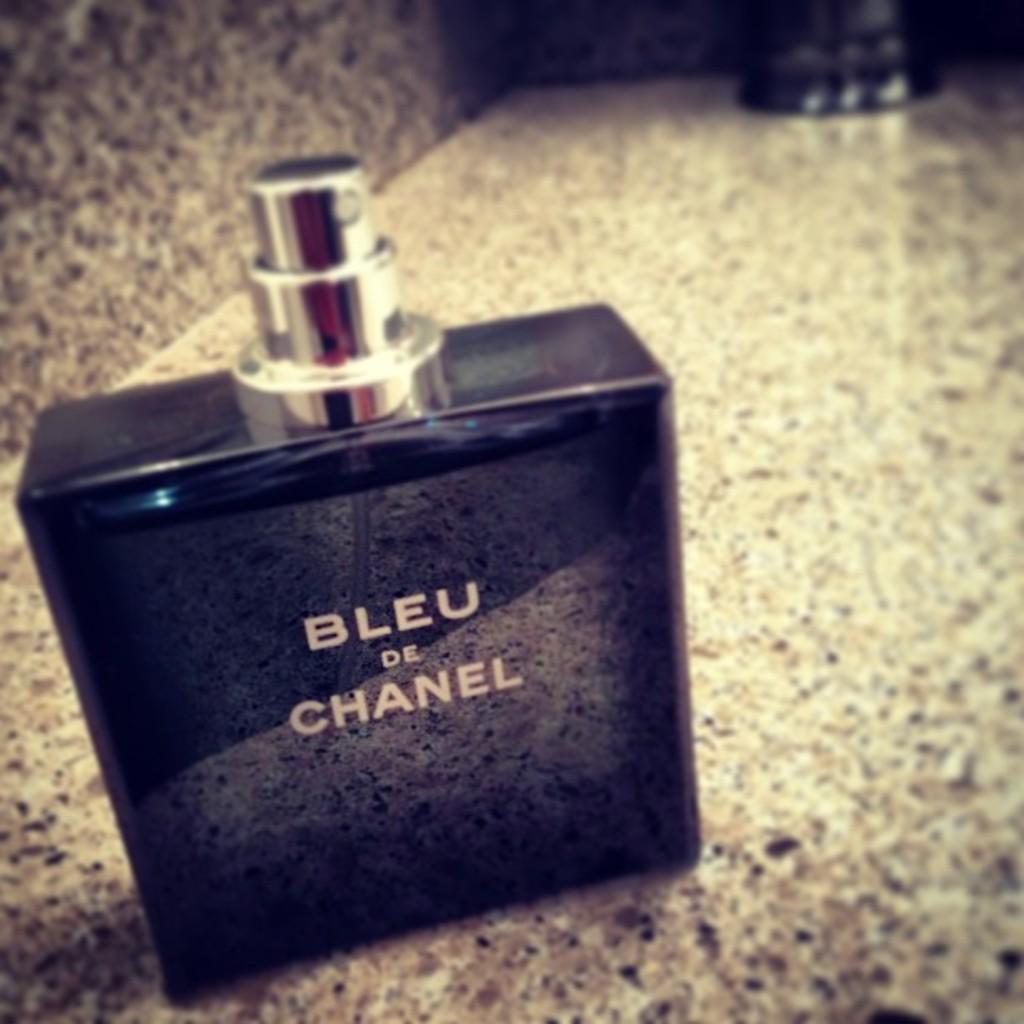What perfume scent is this?
Offer a terse response. Bleu de chanel. What brand is the perfume?
Your answer should be very brief. Chanel. 